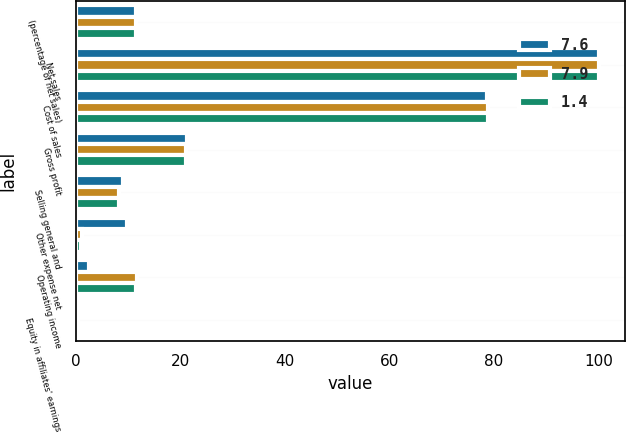Convert chart to OTSL. <chart><loc_0><loc_0><loc_500><loc_500><stacked_bar_chart><ecel><fcel>(percentage of net sales)<fcel>Net sales<fcel>Cost of sales<fcel>Gross profit<fcel>Selling general and<fcel>Other expense net<fcel>Operating income<fcel>Equity in affiliates' earnings<nl><fcel>7.6<fcel>11.6<fcel>100<fcel>78.7<fcel>21.3<fcel>9<fcel>9.8<fcel>2.5<fcel>0.5<nl><fcel>7.9<fcel>11.6<fcel>100<fcel>78.8<fcel>21.2<fcel>8.3<fcel>1.2<fcel>11.7<fcel>0.5<nl><fcel>1.4<fcel>11.6<fcel>100<fcel>78.9<fcel>21.1<fcel>8.4<fcel>1.1<fcel>11.6<fcel>0.6<nl></chart> 